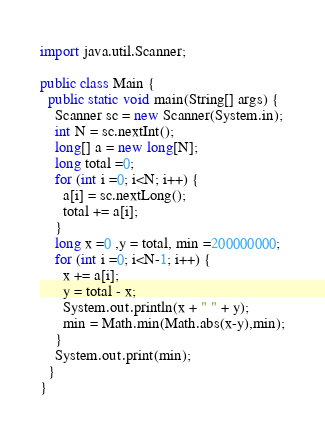Convert code to text. <code><loc_0><loc_0><loc_500><loc_500><_Java_>import java.util.Scanner;

public class Main {  
  public static void main(String[] args) {
    Scanner sc = new Scanner(System.in);
    int N = sc.nextInt();
    long[] a = new long[N];
    long total =0;
    for (int i =0; i<N; i++) {
      a[i] = sc.nextLong();
      total += a[i];
    }
    long x =0 ,y = total, min =200000000;
    for (int i =0; i<N-1; i++) {
      x += a[i];
      y = total - x;
      System.out.println(x + " " + y);
      min = Math.min(Math.abs(x-y),min);
    }
    System.out.print(min);
  }
}</code> 